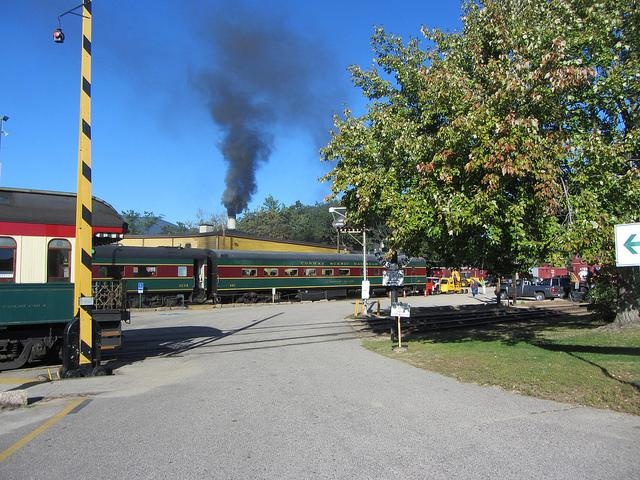In which direction is the train going that is behind the raised arm? left 